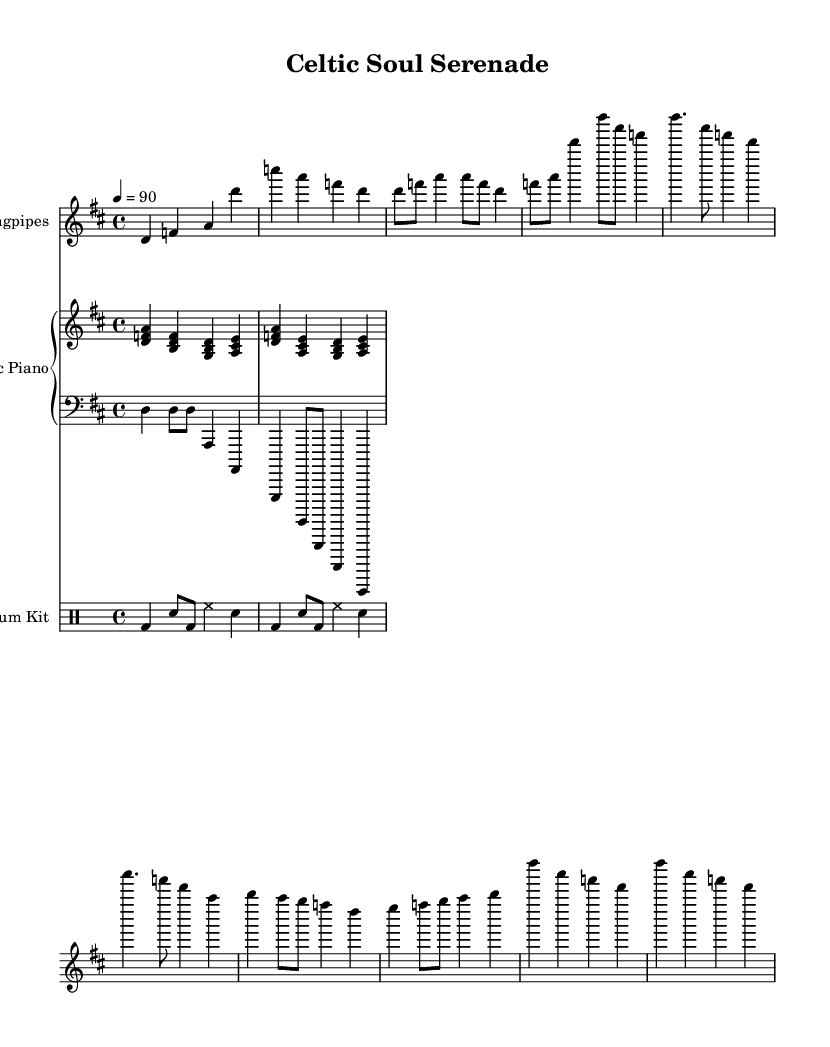What is the key signature of this music? The key signature is D major, which has two sharps: F# and C#.
Answer: D major What is the time signature of this piece? The time signature is 4/4, indicating four beats per measure.
Answer: 4/4 What is the tempo marking for this score? The tempo marking indicates a speed of 90 beats per minute, which is indicated by the tempo fraction "4 = 90".
Answer: 90 How many measures are in the intro section? The intro section consists of 2 measures, evidenced by the notation provided before the verse begins.
Answer: 2 What is the rhythmic pattern used by the drum kit? The drum kit has a syncopated pattern that alternates between bass drum, snare, and hi-hat, which is identifiable in the drum notation.
Answer: Syncopated What type of chords are played by the electric piano? The electric piano plays major and minor triads, as indicated by the chord shapes shown in the notation.
Answer: Major and minor triads How does the bridge section of this music connect to the chorus? The bridge introduces new melodic material before resolving back into the familiar material of the chorus, creating contrast and return, which is a characteristic of R&B structure.
Answer: Contrast and return 